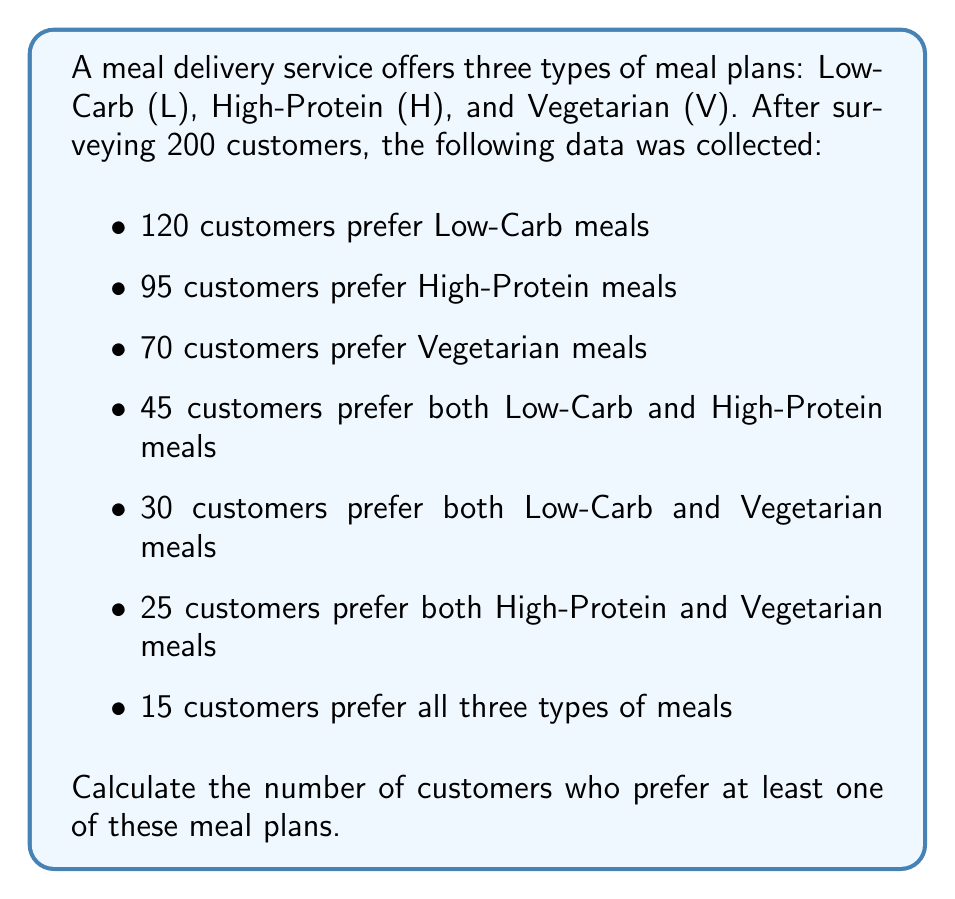Give your solution to this math problem. To solve this problem, we can use the principle of inclusion-exclusion for three sets. Let's define our sets:

$L$ = set of customers preferring Low-Carb meals
$H$ = set of customers preferring High-Protein meals
$V$ = set of customers preferring Vegetarian meals

The principle of inclusion-exclusion for three sets states:

$$|L \cup H \cup V| = |L| + |H| + |V| - |L \cap H| - |L \cap V| - |H \cap V| + |L \cap H \cap V|$$

Where:
$|L| = 120$, $|H| = 95$, $|V| = 70$
$|L \cap H| = 45$, $|L \cap V| = 30$, $|H \cap V| = 25$
$|L \cap H \cap V| = 15$

Substituting these values into the formula:

$$|L \cup H \cup V| = 120 + 95 + 70 - 45 - 30 - 25 + 15$$

$$|L \cup H \cup V| = 285 - 100 + 15$$

$$|L \cup H \cup V| = 200$$

Therefore, 200 customers prefer at least one of these meal plans.
Answer: 200 customers 